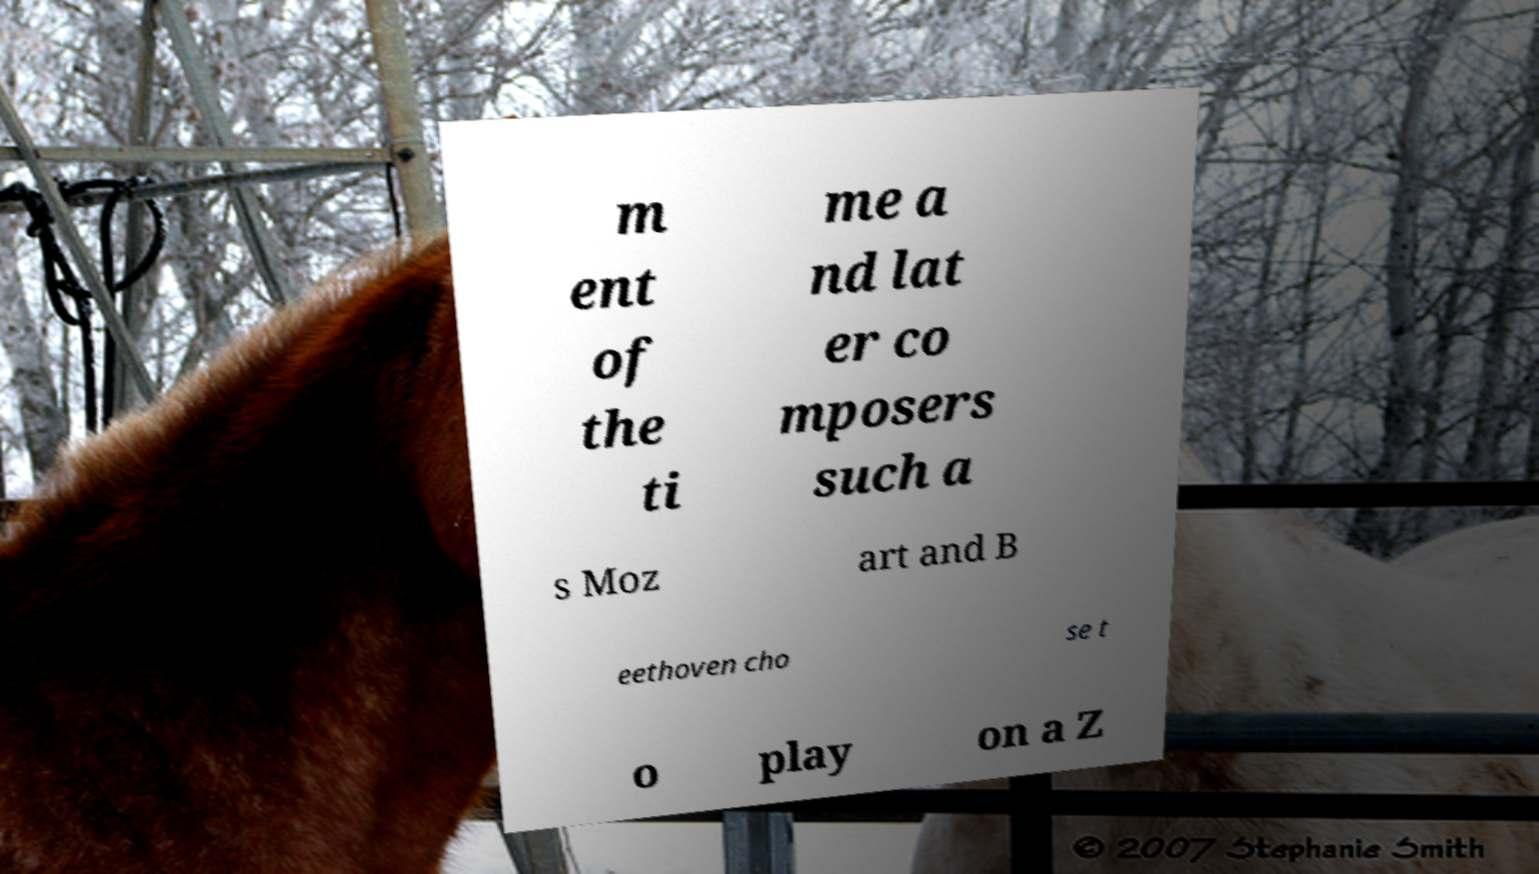There's text embedded in this image that I need extracted. Can you transcribe it verbatim? m ent of the ti me a nd lat er co mposers such a s Moz art and B eethoven cho se t o play on a Z 